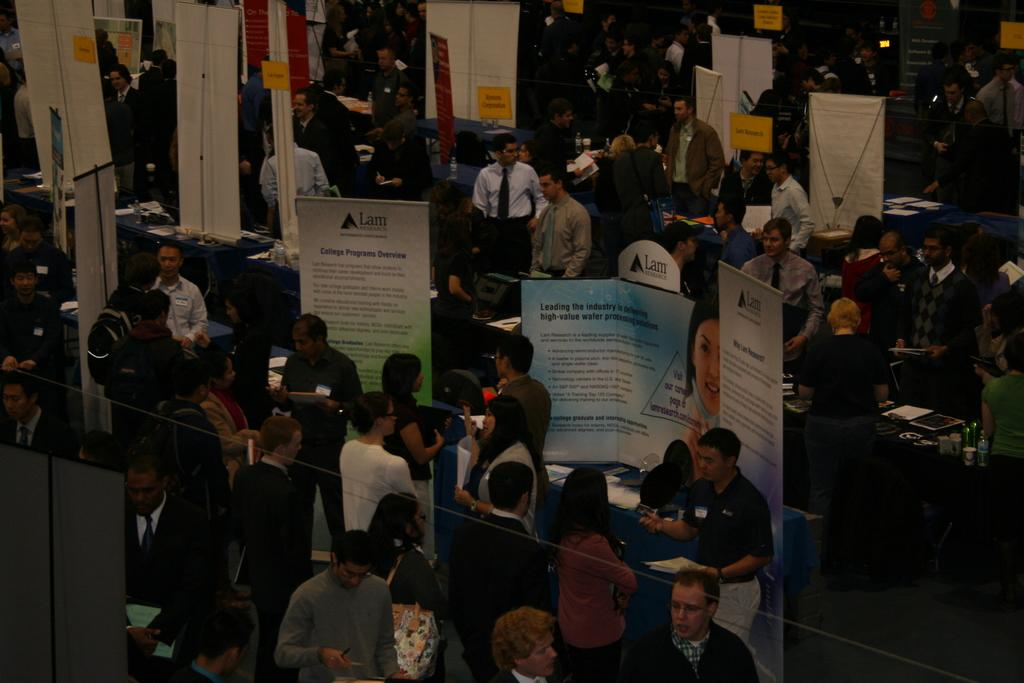What can be seen in the image in terms of people? There are groups of people standing in the image. What else is present in the image besides people? There are banners and boards in the image. Are there any objects on tables in the image? Yes, there are tables with objects on them in the image. What type of pets can be seen learning to kick in the image? There are no pets or any indication of learning or kicking in the image. 